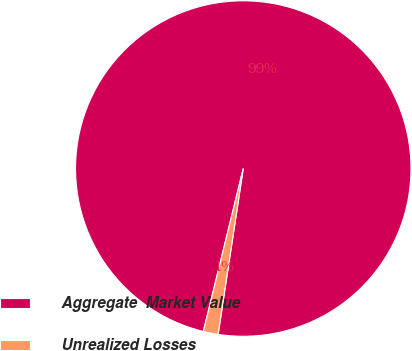Convert chart to OTSL. <chart><loc_0><loc_0><loc_500><loc_500><pie_chart><fcel>Aggregate  Market Value<fcel>Unrealized Losses<nl><fcel>98.57%<fcel>1.43%<nl></chart> 